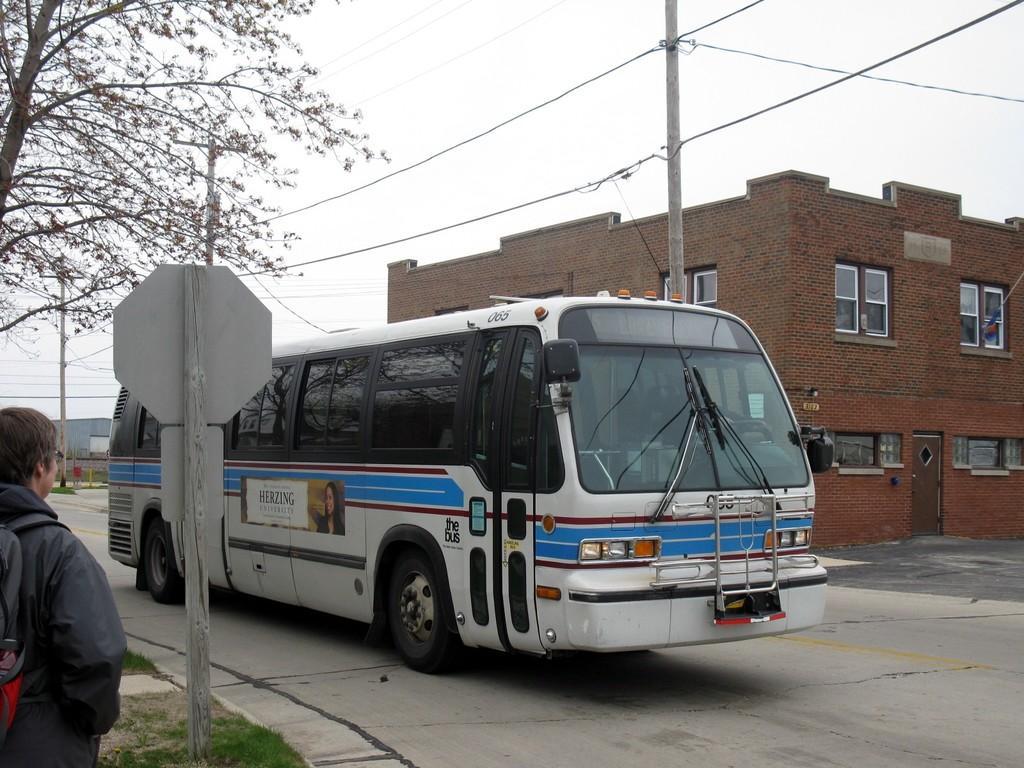Please provide a concise description of this image. In this image I can see a person is standing. Here I can see a bus on the road. In the background I can see a building, wires attached to poles, a tree and the sky. 